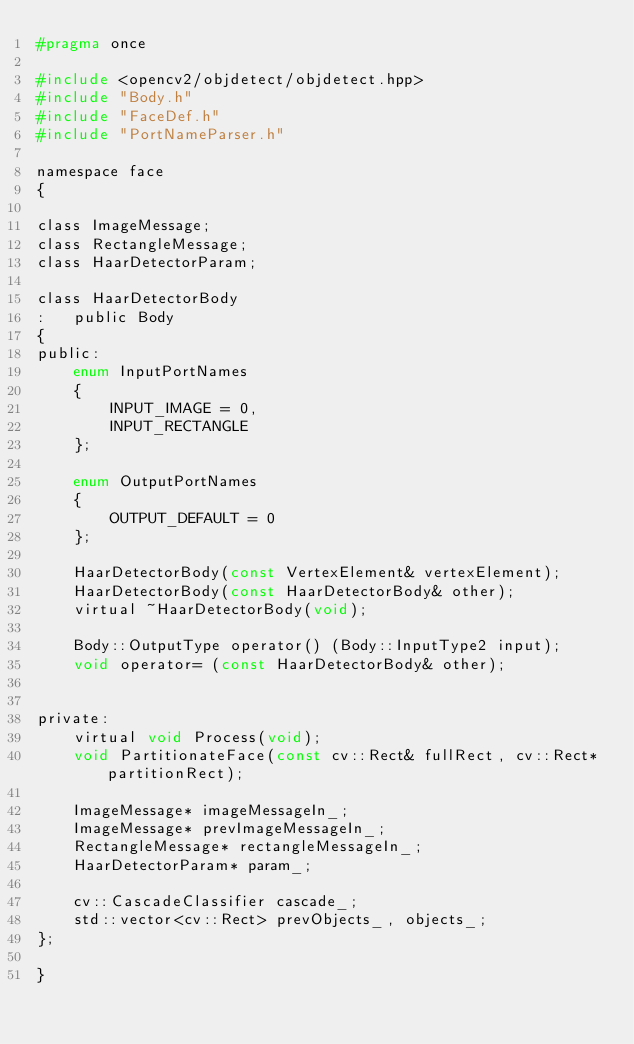<code> <loc_0><loc_0><loc_500><loc_500><_C_>#pragma once

#include <opencv2/objdetect/objdetect.hpp>
#include "Body.h"
#include "FaceDef.h"
#include "PortNameParser.h"

namespace face 
{

class ImageMessage;
class RectangleMessage;
class HaarDetectorParam;

class HaarDetectorBody
:   public Body
{
public:
    enum InputPortNames
    {
        INPUT_IMAGE = 0,
        INPUT_RECTANGLE
    };

    enum OutputPortNames
    {
        OUTPUT_DEFAULT = 0
    };

    HaarDetectorBody(const VertexElement& vertexElement);
    HaarDetectorBody(const HaarDetectorBody& other);
    virtual ~HaarDetectorBody(void);

    Body::OutputType operator() (Body::InputType2 input);
    void operator= (const HaarDetectorBody& other);


private:
    virtual void Process(void);
    void PartitionateFace(const cv::Rect& fullRect, cv::Rect* partitionRect);

    ImageMessage* imageMessageIn_;
	ImageMessage* prevImageMessageIn_;
	RectangleMessage* rectangleMessageIn_;
	HaarDetectorParam* param_;

    cv::CascadeClassifier cascade_;
	std::vector<cv::Rect> prevObjects_, objects_;
};

}
</code> 